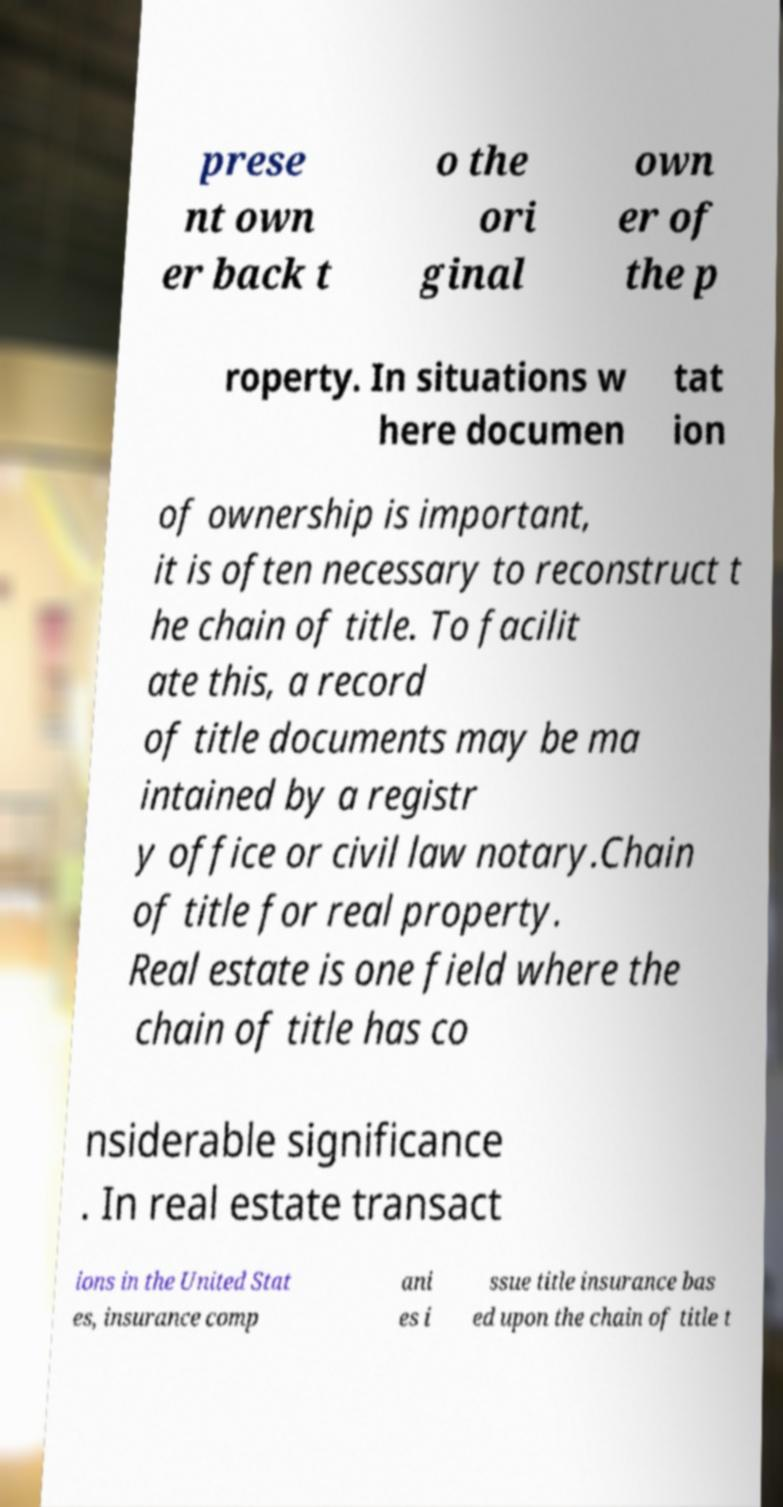I need the written content from this picture converted into text. Can you do that? prese nt own er back t o the ori ginal own er of the p roperty. In situations w here documen tat ion of ownership is important, it is often necessary to reconstruct t he chain of title. To facilit ate this, a record of title documents may be ma intained by a registr y office or civil law notary.Chain of title for real property. Real estate is one field where the chain of title has co nsiderable significance . In real estate transact ions in the United Stat es, insurance comp ani es i ssue title insurance bas ed upon the chain of title t 